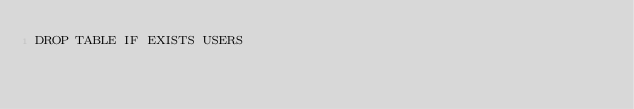Convert code to text. <code><loc_0><loc_0><loc_500><loc_500><_SQL_>DROP TABLE IF EXISTS USERS </code> 